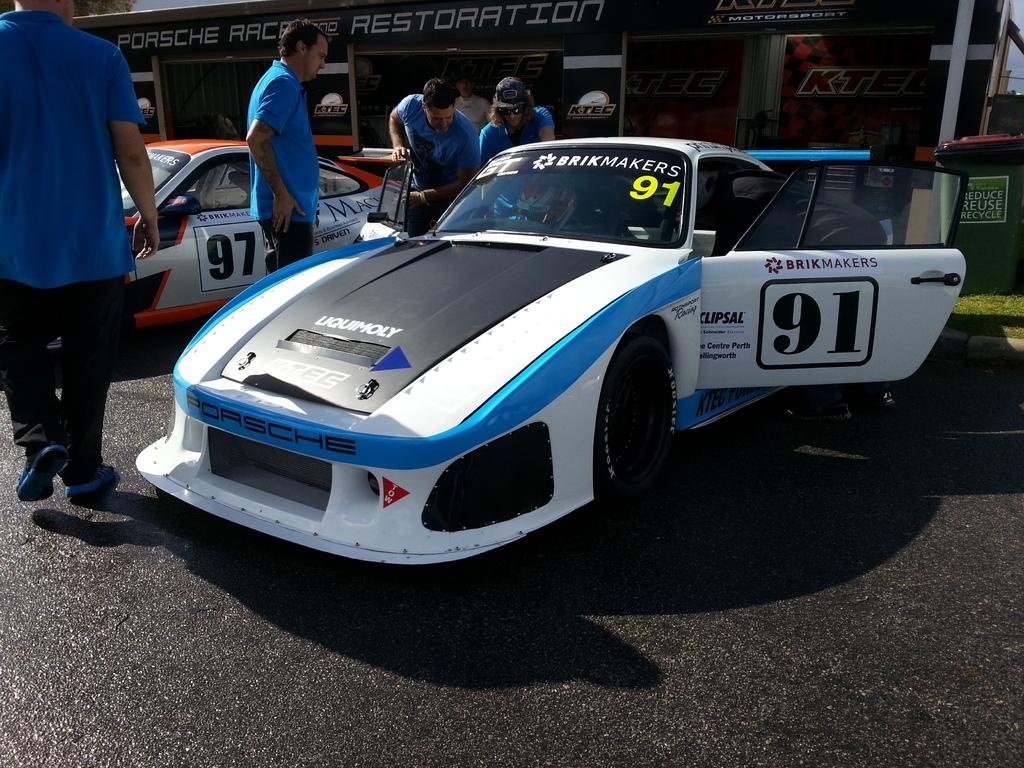What can be seen on the road in the image? There are cars on the road in the image. What are the people doing between the cars? There are people standing between the cars in the image. What can be seen in the distance behind the cars? There is a building visible in the background of the image. Are any of the people wearing masks in the image? There is no information about masks in the image, so we cannot determine if anyone is wearing one. 